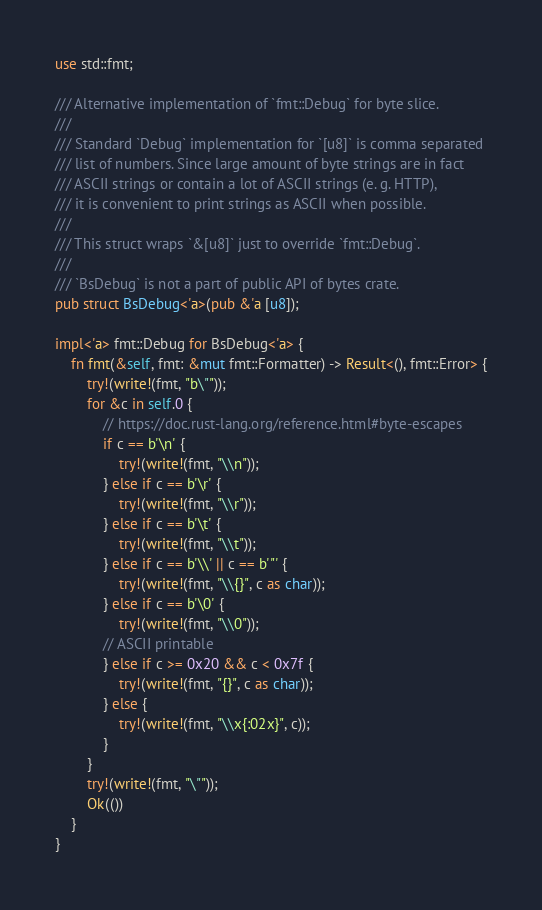Convert code to text. <code><loc_0><loc_0><loc_500><loc_500><_Rust_>use std::fmt;

/// Alternative implementation of `fmt::Debug` for byte slice.
///
/// Standard `Debug` implementation for `[u8]` is comma separated
/// list of numbers. Since large amount of byte strings are in fact
/// ASCII strings or contain a lot of ASCII strings (e. g. HTTP),
/// it is convenient to print strings as ASCII when possible.
///
/// This struct wraps `&[u8]` just to override `fmt::Debug`.
///
/// `BsDebug` is not a part of public API of bytes crate.
pub struct BsDebug<'a>(pub &'a [u8]);

impl<'a> fmt::Debug for BsDebug<'a> {
    fn fmt(&self, fmt: &mut fmt::Formatter) -> Result<(), fmt::Error> {
        try!(write!(fmt, "b\""));
        for &c in self.0 {
            // https://doc.rust-lang.org/reference.html#byte-escapes
            if c == b'\n' {
                try!(write!(fmt, "\\n"));
            } else if c == b'\r' {
                try!(write!(fmt, "\\r"));
            } else if c == b'\t' {
                try!(write!(fmt, "\\t"));
            } else if c == b'\\' || c == b'"' {
                try!(write!(fmt, "\\{}", c as char));
            } else if c == b'\0' {
                try!(write!(fmt, "\\0"));
            // ASCII printable
            } else if c >= 0x20 && c < 0x7f {
                try!(write!(fmt, "{}", c as char));
            } else {
                try!(write!(fmt, "\\x{:02x}", c));
            }
        }
        try!(write!(fmt, "\""));
        Ok(())
    }
}
</code> 